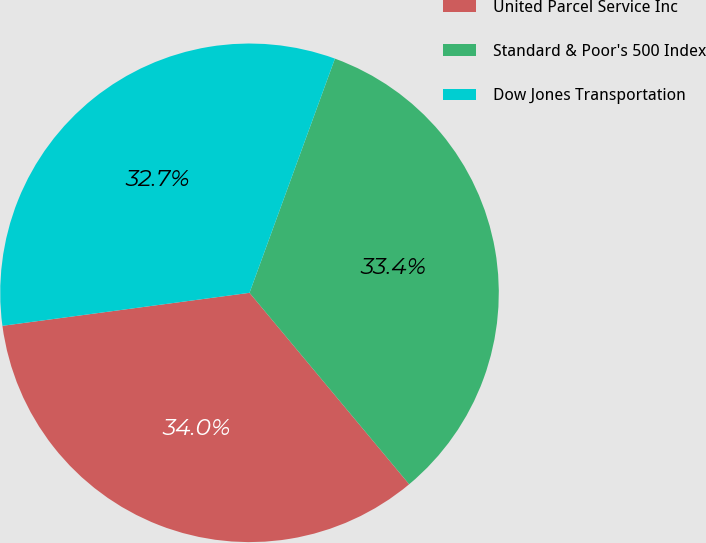Convert chart to OTSL. <chart><loc_0><loc_0><loc_500><loc_500><pie_chart><fcel>United Parcel Service Inc<fcel>Standard & Poor's 500 Index<fcel>Dow Jones Transportation<nl><fcel>33.95%<fcel>33.37%<fcel>32.68%<nl></chart> 